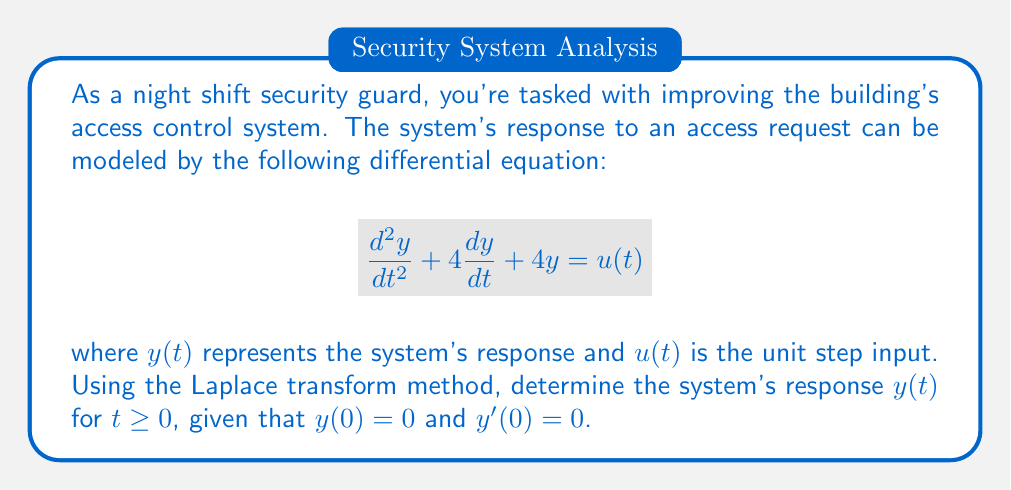Can you solve this math problem? Let's solve this problem step-by-step using the Laplace transform method:

1) First, we take the Laplace transform of both sides of the equation:

   $\mathcal{L}\{y''(t) + 4y'(t) + 4y(t)\} = \mathcal{L}\{u(t)\}$

2) Using Laplace transform properties:

   $[s^2Y(s) - sy(0) - y'(0)] + 4[sY(s) - y(0)] + 4Y(s) = \frac{1}{s}$

3) Substituting the initial conditions $y(0) = 0$ and $y'(0) = 0$:

   $s^2Y(s) + 4sY(s) + 4Y(s) = \frac{1}{s}$

4) Factoring out $Y(s)$:

   $Y(s)(s^2 + 4s + 4) = \frac{1}{s}$

5) Simplifying:

   $Y(s)((s+2)^2) = \frac{1}{s}$

6) Solving for $Y(s)$:

   $Y(s) = \frac{1}{s(s+2)^2}$

7) Using partial fraction decomposition:

   $Y(s) = \frac{A}{s} + \frac{B}{s+2} + \frac{C}{(s+2)^2}$

8) Solving for $A$, $B$, and $C$:

   $A = \frac{1}{4}$, $B = -\frac{1}{2}$, $C = \frac{1}{4}$

9) Therefore:

   $Y(s) = \frac{1}{4s} - \frac{1}{2(s+2)} + \frac{1}{4(s+2)^2}$

10) Taking the inverse Laplace transform:

    $y(t) = \mathcal{L}^{-1}\{Y(s)\} = \frac{1}{4} - \frac{1}{2}e^{-2t} + \frac{1}{4}te^{-2t}$

This is the system's response for $t \geq 0$.
Answer: $y(t) = \frac{1}{4} - \frac{1}{2}e^{-2t} + \frac{1}{4}te^{-2t}$ 